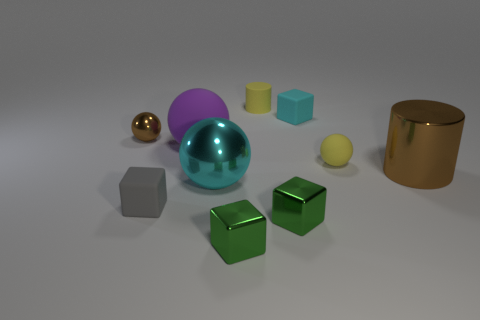Is there a metallic cylinder of the same color as the big metallic ball?
Offer a very short reply. No. The metallic cylinder that is the same size as the purple sphere is what color?
Ensure brevity in your answer.  Brown. What shape is the brown metallic thing behind the yellow rubber thing in front of the brown metal thing to the left of the purple thing?
Your answer should be compact. Sphere. There is a large shiny cylinder that is behind the big cyan thing; how many cyan things are in front of it?
Ensure brevity in your answer.  1. Do the yellow rubber object behind the brown ball and the cyan object that is behind the cyan sphere have the same shape?
Your response must be concise. No. There is a large purple thing; how many gray matte objects are to the right of it?
Your response must be concise. 0. Do the brown object that is in front of the large purple matte sphere and the large purple ball have the same material?
Offer a terse response. No. What color is the other tiny object that is the same shape as the small brown thing?
Your answer should be compact. Yellow. The small cyan thing has what shape?
Provide a succinct answer. Cube. What number of objects are large purple rubber spheres or tiny green cylinders?
Provide a short and direct response. 1. 